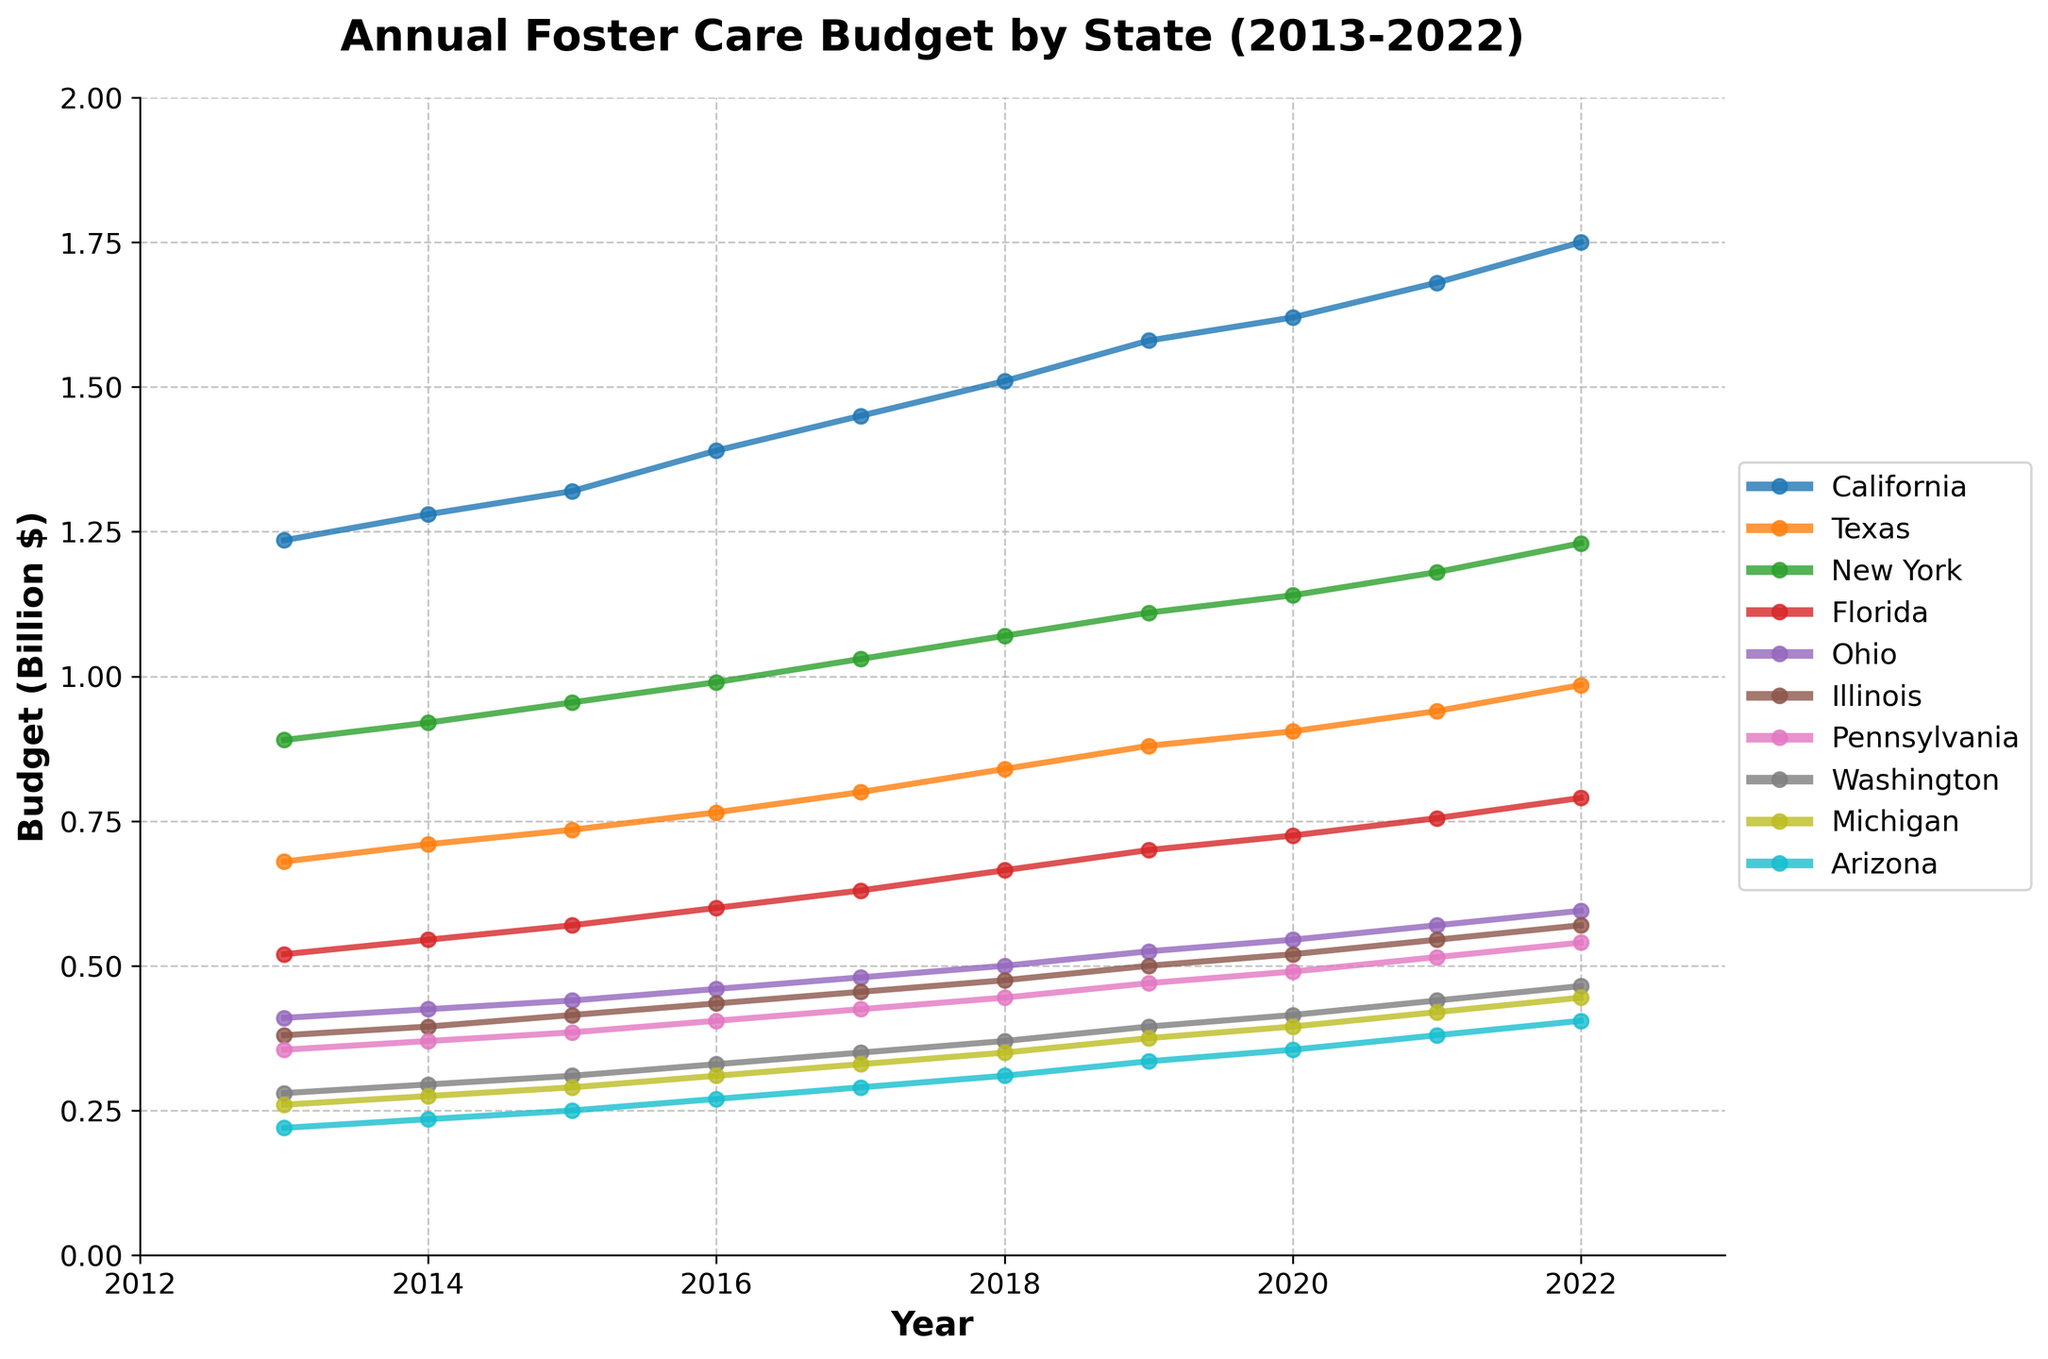Which state had the highest budget allocation for foster care services in 2022? By looking at the graph, identify the state with the highest plotted point in 2022. This corresponds to the budget for that year.
Answer: California How much did Texas' budget for foster care services increase from 2013 to 2022? Observe the plotted points for Texas in 2013 and 2022, subtract the value for 2013 from the value for 2022. The increase can be calculated as 985 million - 680 million = 305 million.
Answer: 305 million Which state had the smallest budget allocation in 2013? Check the plotted points for all states in 2013 and identify the lowest plotted point.
Answer: Arizona Between which two consecutive years did New York's foster care budget see the largest increase? Calculate the year-on-year difference for New York's budget. Identify which pair of consecutive years has the maximum difference. For New York, the difference is largest between 2021 and 2022 where it increased from 1180 million to 1230 million (50 million).
Answer: 2021 to 2022 Compare the budget trajectories of California and Florida. Which state showed a steadier increase over the years? Look at the trend of plotted points for both California and Florida. California has a consistently upward trend without sharp fluctuations, while Florida also increases but can have minor variations. California's increase appears steadier.
Answer: California Which state experienced the most significant percentage increase in budget allocation from 2013 to 2022? Calculate the percentage increase for each state from 2013 to 2022 using the formula: ((2022 value - 2013 value)/2013 value) * 100. Compare the percentages to find the highest. For example, Arizona's increase is ((405-220)/220) * 100 ≈ 84.09%. Perform similar calculations for each state.
Answer: Arizona By how much did the budget allocation for foster care services in Illinois increase from 2016 to 2020? Observe the plotted points for Illinois in 2016 and 2020, then subtract the value for 2016 from the value for 2020 which is 520 million - 435 million = 85 million.
Answer: 85 million Which states had a budget allocation greater than 1 billion dollars in 2019? Look at the plotted points for 2019 and identify the states whose points are above 1 billion on the y-axis. The states meeting this criterion are California, Texas, and New York.
Answer: California, Texas, New York 